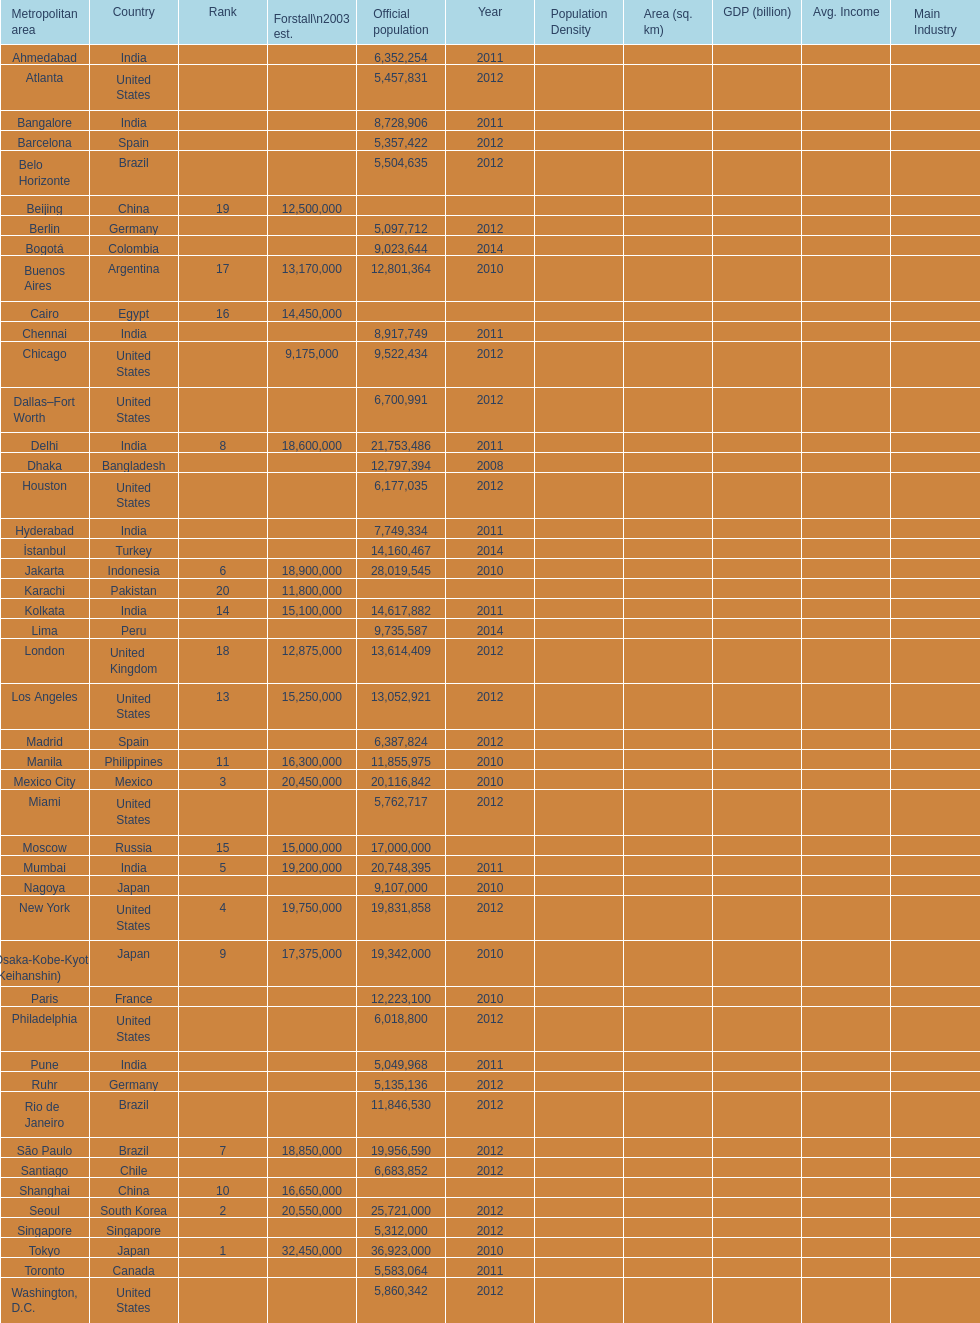Which area is listed above chicago? Chennai. Can you give me this table as a dict? {'header': ['Metropolitan area', 'Country', 'Rank', 'Forstall\\n2003 est.', 'Official population', 'Year', 'Population Density', 'Area (sq. km)', 'GDP (billion)', 'Avg. Income', 'Main Industry'], 'rows': [['Ahmedabad', 'India', '', '', '6,352,254', '2011', '', '', '', '', ''], ['Atlanta', 'United States', '', '', '5,457,831', '2012', '', '', '', '', ''], ['Bangalore', 'India', '', '', '8,728,906', '2011', '', '', '', '', ''], ['Barcelona', 'Spain', '', '', '5,357,422', '2012', '', '', '', '', ''], ['Belo Horizonte', 'Brazil', '', '', '5,504,635', '2012', '', '', '', '', ''], ['Beijing', 'China', '19', '12,500,000', '', '', '', '', '', '', ''], ['Berlin', 'Germany', '', '', '5,097,712', '2012', '', '', '', '', ''], ['Bogotá', 'Colombia', '', '', '9,023,644', '2014', '', '', '', '', ''], ['Buenos Aires', 'Argentina', '17', '13,170,000', '12,801,364', '2010', '', '', '', '', ''], ['Cairo', 'Egypt', '16', '14,450,000', '', '', '', '', '', '', ''], ['Chennai', 'India', '', '', '8,917,749', '2011', '', '', '', '', ''], ['Chicago', 'United States', '', '9,175,000', '9,522,434', '2012', '', '', '', '', ''], ['Dallas–Fort Worth', 'United States', '', '', '6,700,991', '2012', '', '', '', '', ''], ['Delhi', 'India', '8', '18,600,000', '21,753,486', '2011', '', '', '', '', ''], ['Dhaka', 'Bangladesh', '', '', '12,797,394', '2008', '', '', '', '', ''], ['Houston', 'United States', '', '', '6,177,035', '2012', '', '', '', '', ''], ['Hyderabad', 'India', '', '', '7,749,334', '2011', '', '', '', '', ''], ['İstanbul', 'Turkey', '', '', '14,160,467', '2014', '', '', '', '', ''], ['Jakarta', 'Indonesia', '6', '18,900,000', '28,019,545', '2010', '', '', '', '', ''], ['Karachi', 'Pakistan', '20', '11,800,000', '', '', '', '', '', '', ''], ['Kolkata', 'India', '14', '15,100,000', '14,617,882', '2011', '', '', '', '', ''], ['Lima', 'Peru', '', '', '9,735,587', '2014', '', '', '', '', ''], ['London', 'United Kingdom', '18', '12,875,000', '13,614,409', '2012', '', '', '', '', ''], ['Los Angeles', 'United States', '13', '15,250,000', '13,052,921', '2012', '', '', '', '', ''], ['Madrid', 'Spain', '', '', '6,387,824', '2012', '', '', '', '', ''], ['Manila', 'Philippines', '11', '16,300,000', '11,855,975', '2010', '', '', '', '', ''], ['Mexico City', 'Mexico', '3', '20,450,000', '20,116,842', '2010', '', '', '', '', ''], ['Miami', 'United States', '', '', '5,762,717', '2012', '', '', '', '', ''], ['Moscow', 'Russia', '15', '15,000,000', '17,000,000', '', '', '', '', '', ''], ['Mumbai', 'India', '5', '19,200,000', '20,748,395', '2011', '', '', '', '', ''], ['Nagoya', 'Japan', '', '', '9,107,000', '2010', '', '', '', '', ''], ['New York', 'United States', '4', '19,750,000', '19,831,858', '2012', '', '', '', '', ''], ['Osaka-Kobe-Kyoto (Keihanshin)', 'Japan', '9', '17,375,000', '19,342,000', '2010', '', '', '', '', ''], ['Paris', 'France', '', '', '12,223,100', '2010', '', '', '', '', ''], ['Philadelphia', 'United States', '', '', '6,018,800', '2012', '', '', '', '', ''], ['Pune', 'India', '', '', '5,049,968', '2011', '', '', '', '', ''], ['Ruhr', 'Germany', '', '', '5,135,136', '2012', '', '', '', '', ''], ['Rio de Janeiro', 'Brazil', '', '', '11,846,530', '2012', '', '', '', '', ''], ['São Paulo', 'Brazil', '7', '18,850,000', '19,956,590', '2012', '', '', '', '', ''], ['Santiago', 'Chile', '', '', '6,683,852', '2012', '', '', '', '', ''], ['Shanghai', 'China', '10', '16,650,000', '', '', '', '', '', '', ''], ['Seoul', 'South Korea', '2', '20,550,000', '25,721,000', '2012', '', '', '', '', ''], ['Singapore', 'Singapore', '', '', '5,312,000', '2012', '', '', '', '', ''], ['Tokyo', 'Japan', '1', '32,450,000', '36,923,000', '2010', '', '', '', '', ''], ['Toronto', 'Canada', '', '', '5,583,064', '2011', '', '', '', '', ''], ['Washington, D.C.', 'United States', '', '', '5,860,342', '2012', '', '', '', '', '']]} 